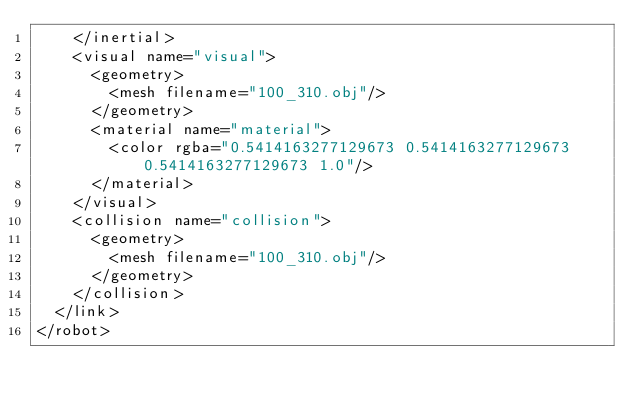<code> <loc_0><loc_0><loc_500><loc_500><_XML_>    </inertial>
    <visual name="visual">
      <geometry>
        <mesh filename="100_310.obj"/>
      </geometry>
      <material name="material">
        <color rgba="0.5414163277129673 0.5414163277129673 0.5414163277129673 1.0"/>
      </material>
    </visual>
    <collision name="collision">
      <geometry>
        <mesh filename="100_310.obj"/>
      </geometry>
    </collision>
  </link>
</robot>
</code> 